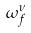<formula> <loc_0><loc_0><loc_500><loc_500>\omega _ { f } ^ { \nu }</formula> 